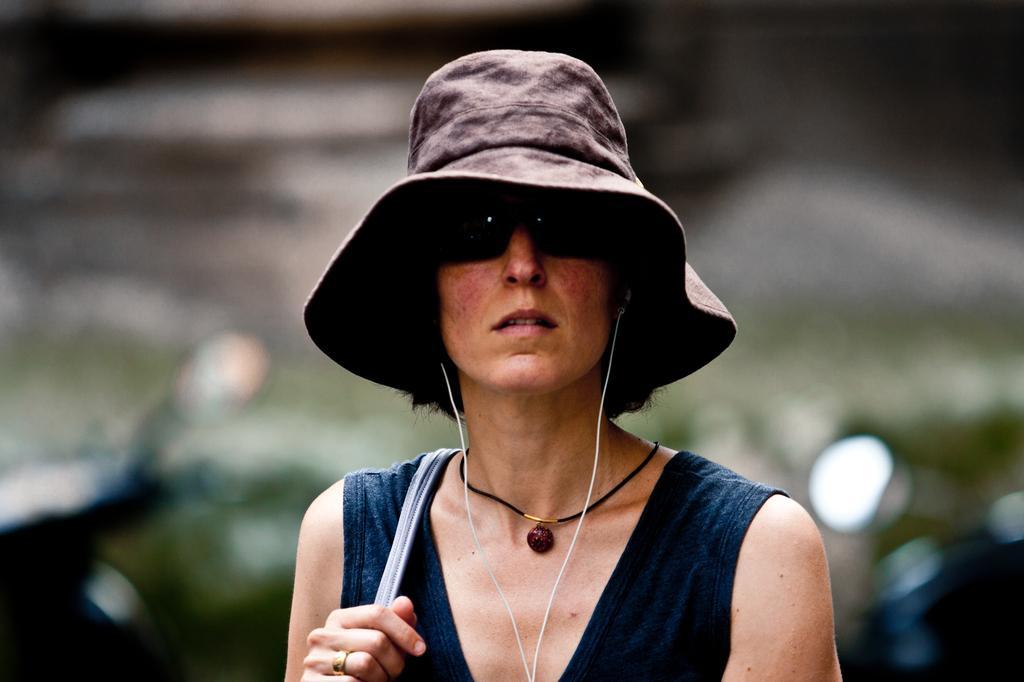Could you give a brief overview of what you see in this image? In this image I can see a woman in the front. I can see she is wearing a black shades, a hat, a black top and I can see she is holding a belt. I can also see she is using an earphone. I can also see this image is blurry in the background. 